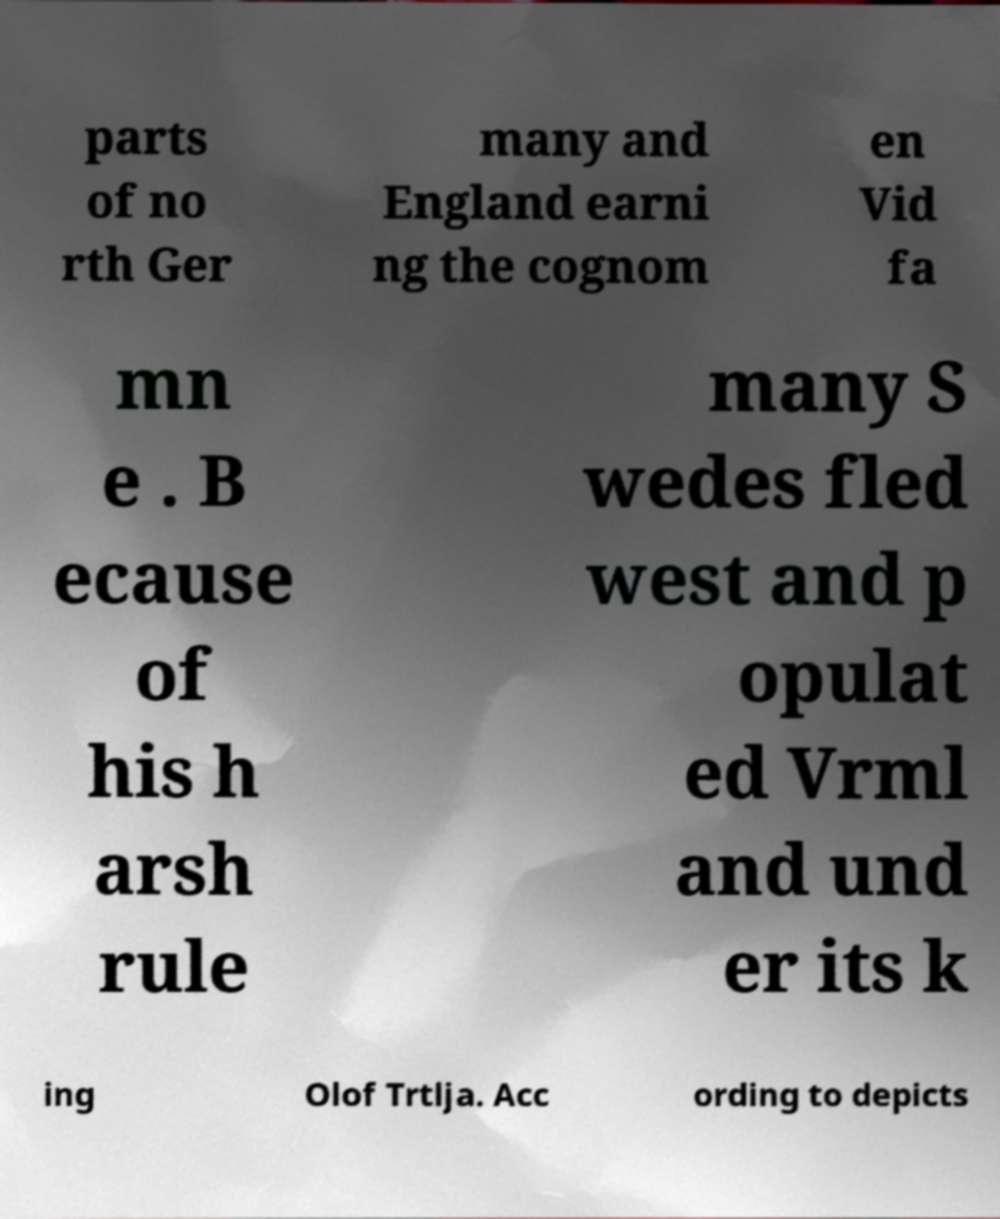For documentation purposes, I need the text within this image transcribed. Could you provide that? parts of no rth Ger many and England earni ng the cognom en Vid fa mn e . B ecause of his h arsh rule many S wedes fled west and p opulat ed Vrml and und er its k ing Olof Trtlja. Acc ording to depicts 